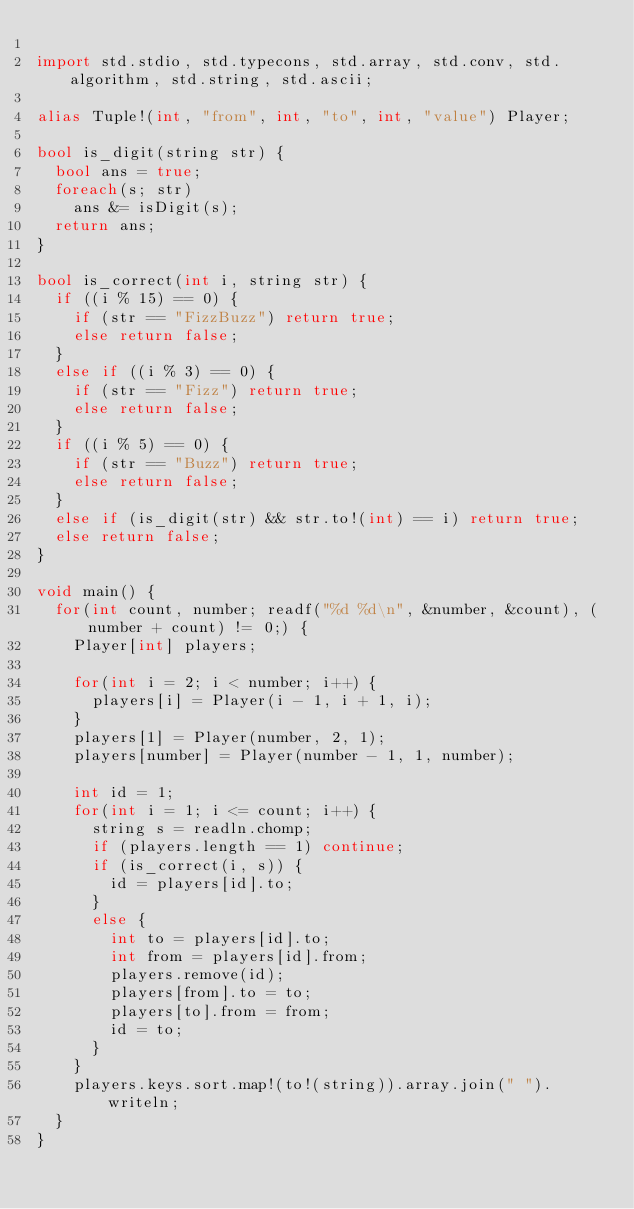Convert code to text. <code><loc_0><loc_0><loc_500><loc_500><_D_>
import std.stdio, std.typecons, std.array, std.conv, std.algorithm, std.string, std.ascii;

alias Tuple!(int, "from", int, "to", int, "value") Player;

bool is_digit(string str) {
  bool ans = true;
  foreach(s; str)
    ans &= isDigit(s);
  return ans;
}

bool is_correct(int i, string str) {
  if ((i % 15) == 0) {
    if (str == "FizzBuzz") return true;
    else return false;
  }
  else if ((i % 3) == 0) {
    if (str == "Fizz") return true;
    else return false;
  }
  if ((i % 5) == 0) {
    if (str == "Buzz") return true;
    else return false;
  }
  else if (is_digit(str) && str.to!(int) == i) return true;
  else return false;
}

void main() {
  for(int count, number; readf("%d %d\n", &number, &count), (number + count) != 0;) {
    Player[int] players;

    for(int i = 2; i < number; i++) {
      players[i] = Player(i - 1, i + 1, i);
    }
    players[1] = Player(number, 2, 1);
    players[number] = Player(number - 1, 1, number);

    int id = 1;
    for(int i = 1; i <= count; i++) {
      string s = readln.chomp;
      if (players.length == 1) continue;
      if (is_correct(i, s)) {
        id = players[id].to;
      }
      else {
        int to = players[id].to;
        int from = players[id].from;
        players.remove(id);
        players[from].to = to;
        players[to].from = from;
        id = to;
      }
    }
    players.keys.sort.map!(to!(string)).array.join(" ").writeln;
  }
}</code> 